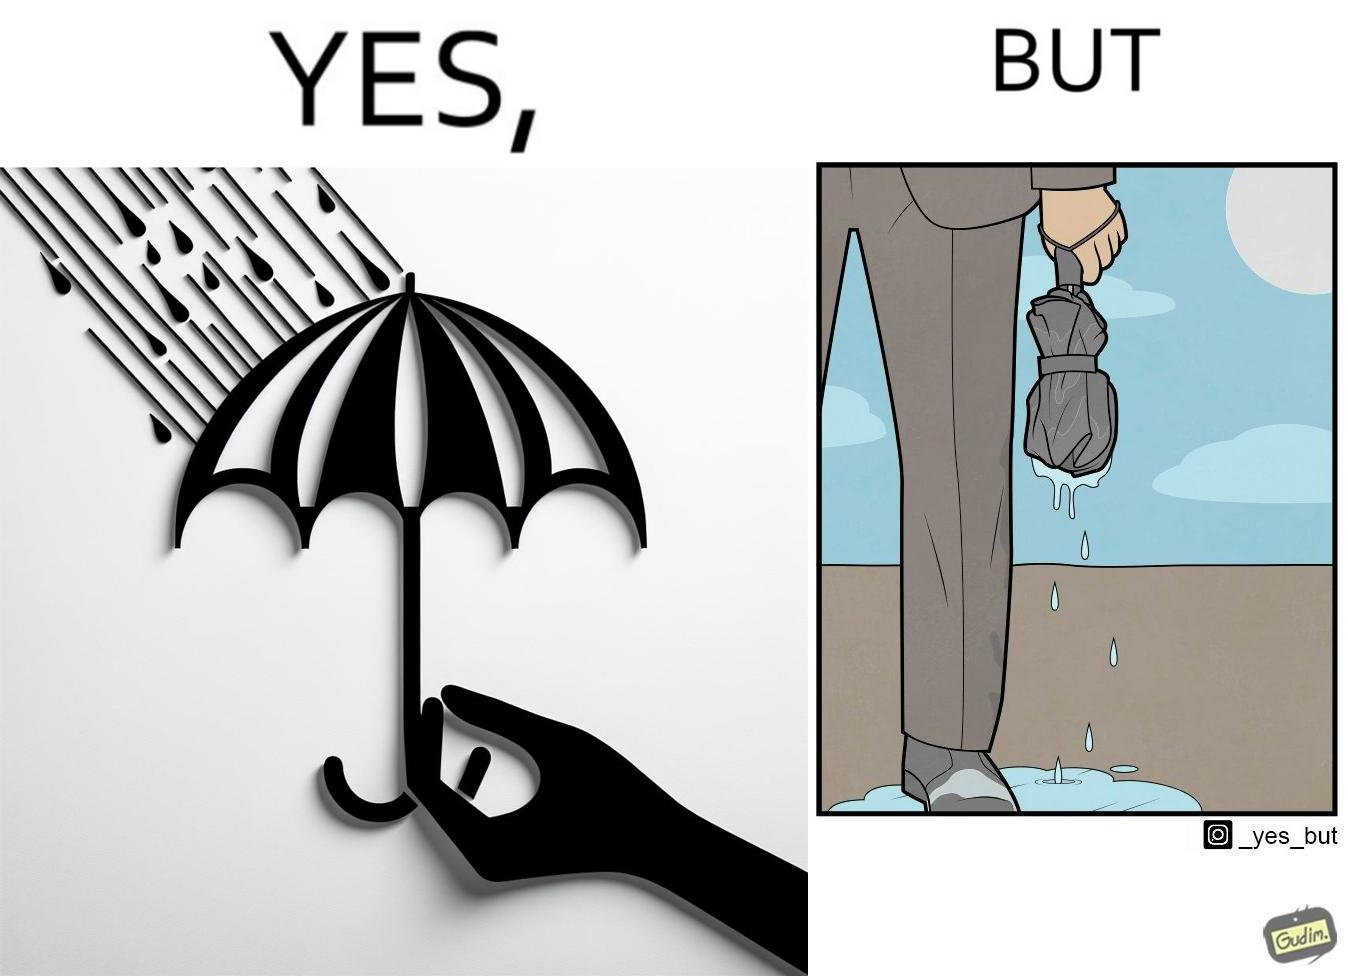Is this image satirical or non-satirical? Yes, this image is satirical. 